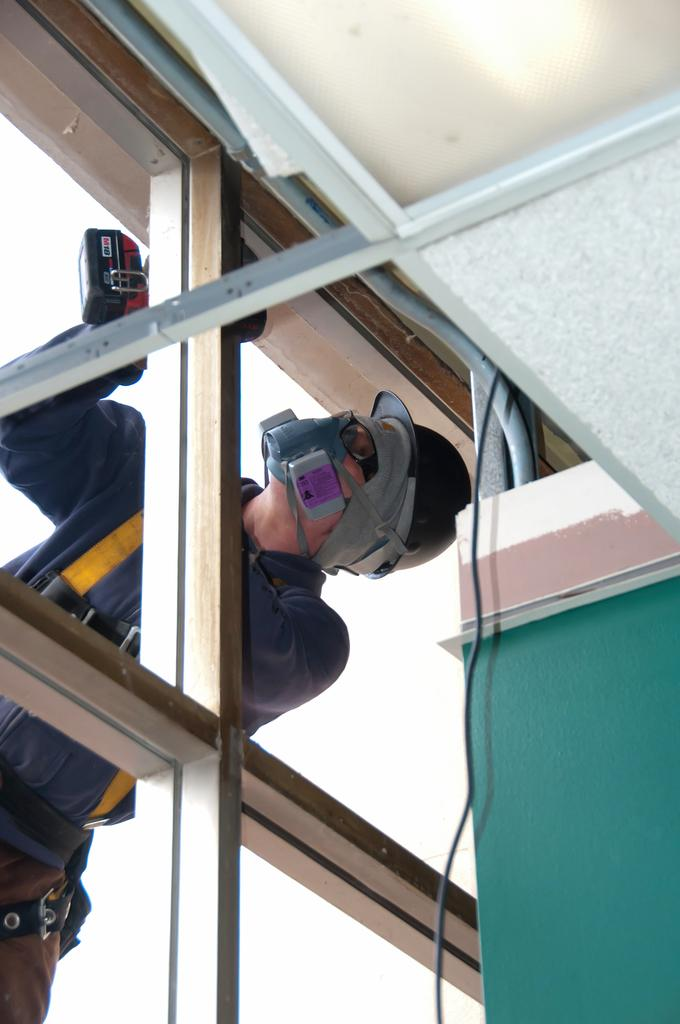What is the main setting of the image? The image is of a room. Who or what can be seen in the room? There is a person with a helmet in the room. Where is the person located in the room? The person is standing beside a window. What other objects can be seen in the image? There is a pipe and wire visible at the top of the image, as well as a light. What grade is the person in the image? There is no information about the person's grade in the image. How many fingers does the person have in the image? The image does not show the person's fingers, so it cannot be determined from the image. 